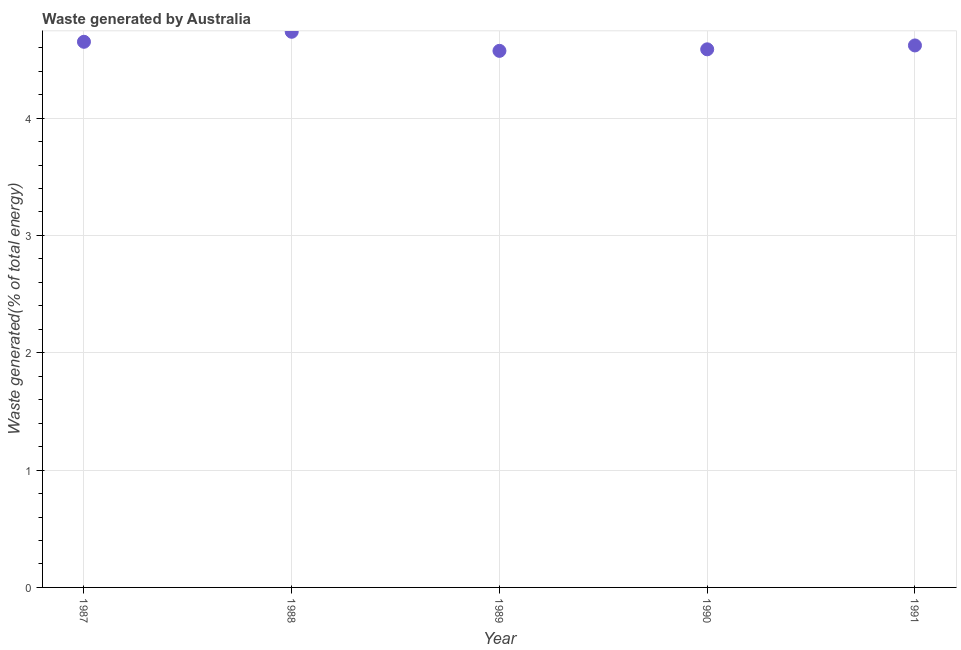What is the amount of waste generated in 1988?
Provide a succinct answer. 4.74. Across all years, what is the maximum amount of waste generated?
Your response must be concise. 4.74. Across all years, what is the minimum amount of waste generated?
Your answer should be very brief. 4.57. In which year was the amount of waste generated minimum?
Your answer should be compact. 1989. What is the sum of the amount of waste generated?
Offer a terse response. 23.16. What is the difference between the amount of waste generated in 1987 and 1990?
Make the answer very short. 0.06. What is the average amount of waste generated per year?
Offer a very short reply. 4.63. What is the median amount of waste generated?
Your answer should be very brief. 4.62. In how many years, is the amount of waste generated greater than 3 %?
Your response must be concise. 5. Do a majority of the years between 1991 and 1989 (inclusive) have amount of waste generated greater than 2.2 %?
Ensure brevity in your answer.  No. What is the ratio of the amount of waste generated in 1990 to that in 1991?
Provide a succinct answer. 0.99. Is the amount of waste generated in 1988 less than that in 1990?
Ensure brevity in your answer.  No. What is the difference between the highest and the second highest amount of waste generated?
Keep it short and to the point. 0.09. What is the difference between the highest and the lowest amount of waste generated?
Offer a very short reply. 0.16. How many dotlines are there?
Your answer should be very brief. 1. What is the difference between two consecutive major ticks on the Y-axis?
Your answer should be compact. 1. Does the graph contain grids?
Your answer should be compact. Yes. What is the title of the graph?
Ensure brevity in your answer.  Waste generated by Australia. What is the label or title of the Y-axis?
Your response must be concise. Waste generated(% of total energy). What is the Waste generated(% of total energy) in 1987?
Give a very brief answer. 4.65. What is the Waste generated(% of total energy) in 1988?
Provide a short and direct response. 4.74. What is the Waste generated(% of total energy) in 1989?
Give a very brief answer. 4.57. What is the Waste generated(% of total energy) in 1990?
Keep it short and to the point. 4.59. What is the Waste generated(% of total energy) in 1991?
Offer a terse response. 4.62. What is the difference between the Waste generated(% of total energy) in 1987 and 1988?
Your answer should be compact. -0.09. What is the difference between the Waste generated(% of total energy) in 1987 and 1989?
Ensure brevity in your answer.  0.08. What is the difference between the Waste generated(% of total energy) in 1987 and 1990?
Keep it short and to the point. 0.06. What is the difference between the Waste generated(% of total energy) in 1987 and 1991?
Make the answer very short. 0.03. What is the difference between the Waste generated(% of total energy) in 1988 and 1989?
Offer a very short reply. 0.16. What is the difference between the Waste generated(% of total energy) in 1988 and 1990?
Offer a terse response. 0.15. What is the difference between the Waste generated(% of total energy) in 1988 and 1991?
Provide a succinct answer. 0.12. What is the difference between the Waste generated(% of total energy) in 1989 and 1990?
Provide a succinct answer. -0.01. What is the difference between the Waste generated(% of total energy) in 1989 and 1991?
Your answer should be very brief. -0.05. What is the difference between the Waste generated(% of total energy) in 1990 and 1991?
Provide a succinct answer. -0.03. What is the ratio of the Waste generated(% of total energy) in 1987 to that in 1990?
Offer a terse response. 1.01. What is the ratio of the Waste generated(% of total energy) in 1987 to that in 1991?
Keep it short and to the point. 1.01. What is the ratio of the Waste generated(% of total energy) in 1988 to that in 1989?
Your answer should be compact. 1.04. What is the ratio of the Waste generated(% of total energy) in 1988 to that in 1990?
Offer a terse response. 1.03. What is the ratio of the Waste generated(% of total energy) in 1988 to that in 1991?
Offer a terse response. 1.02. What is the ratio of the Waste generated(% of total energy) in 1989 to that in 1990?
Make the answer very short. 1. What is the ratio of the Waste generated(% of total energy) in 1990 to that in 1991?
Offer a terse response. 0.99. 